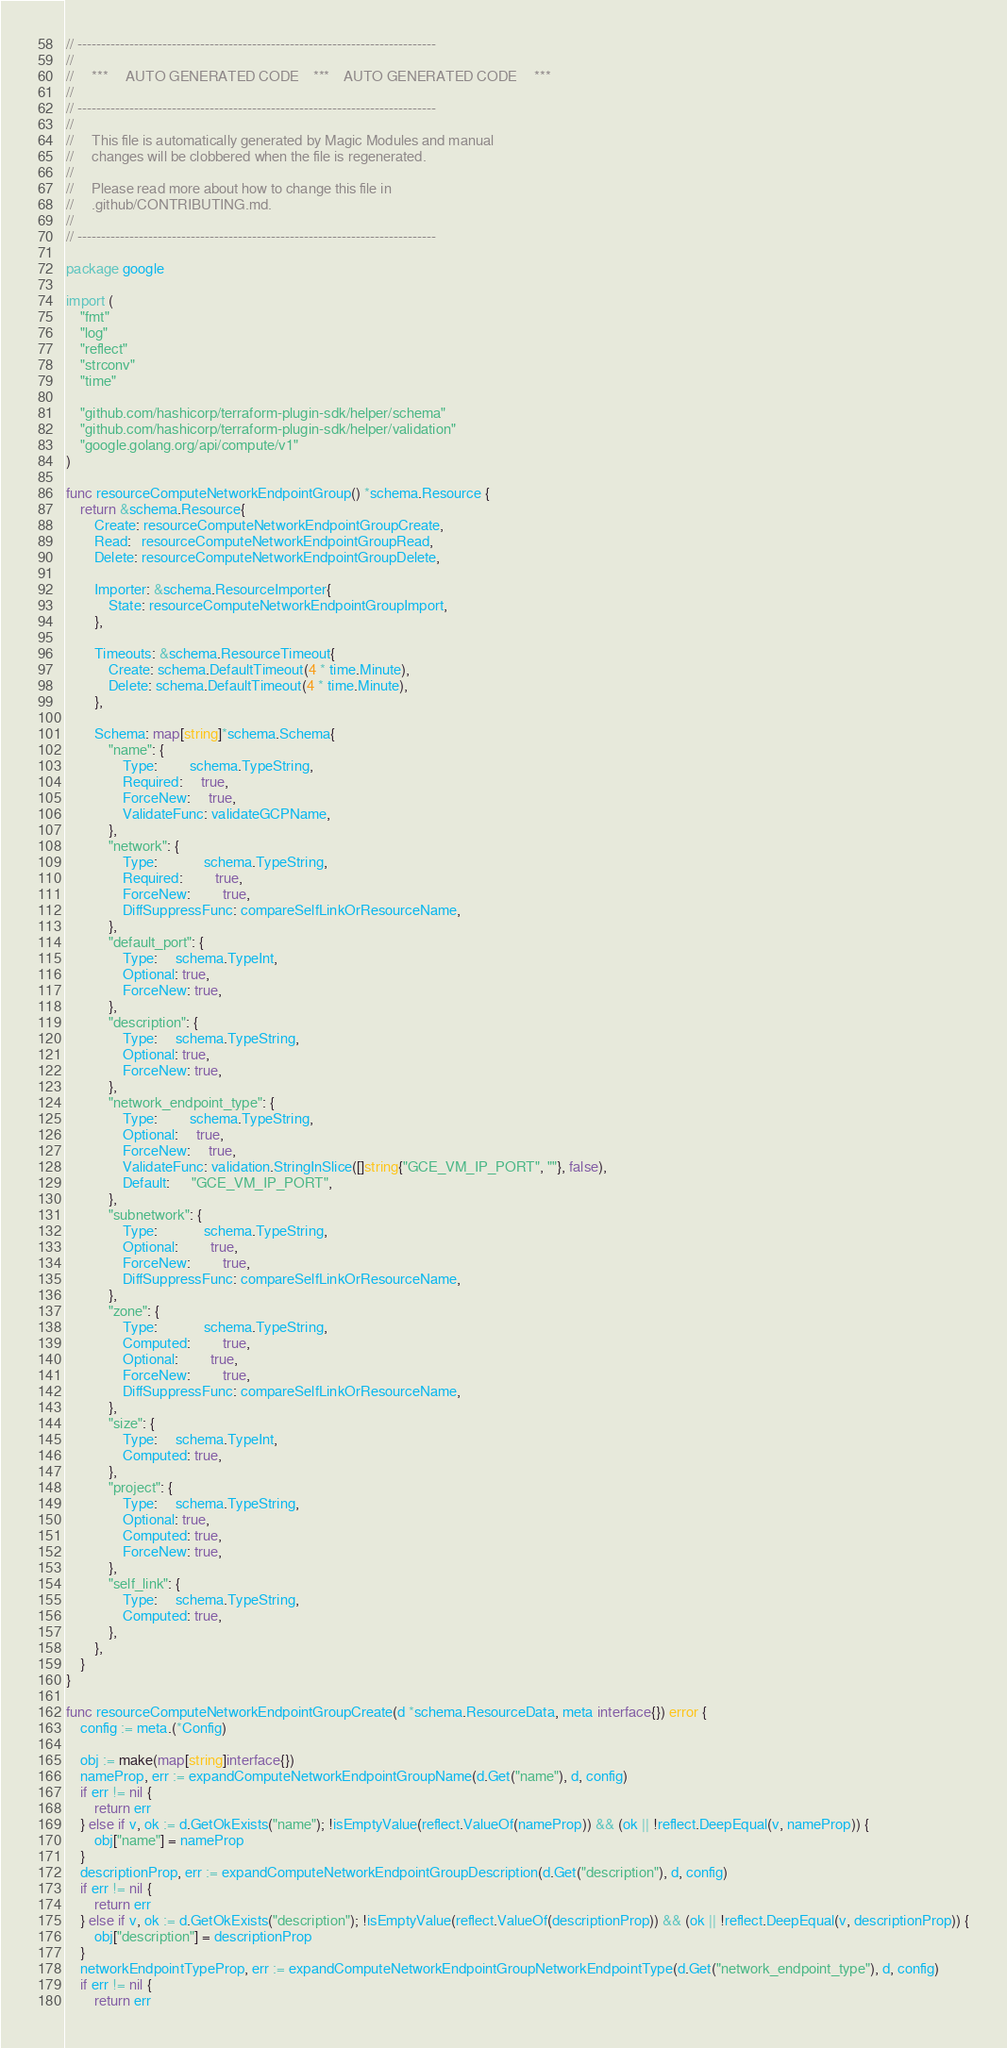<code> <loc_0><loc_0><loc_500><loc_500><_Go_>// ----------------------------------------------------------------------------
//
//     ***     AUTO GENERATED CODE    ***    AUTO GENERATED CODE     ***
//
// ----------------------------------------------------------------------------
//
//     This file is automatically generated by Magic Modules and manual
//     changes will be clobbered when the file is regenerated.
//
//     Please read more about how to change this file in
//     .github/CONTRIBUTING.md.
//
// ----------------------------------------------------------------------------

package google

import (
	"fmt"
	"log"
	"reflect"
	"strconv"
	"time"

	"github.com/hashicorp/terraform-plugin-sdk/helper/schema"
	"github.com/hashicorp/terraform-plugin-sdk/helper/validation"
	"google.golang.org/api/compute/v1"
)

func resourceComputeNetworkEndpointGroup() *schema.Resource {
	return &schema.Resource{
		Create: resourceComputeNetworkEndpointGroupCreate,
		Read:   resourceComputeNetworkEndpointGroupRead,
		Delete: resourceComputeNetworkEndpointGroupDelete,

		Importer: &schema.ResourceImporter{
			State: resourceComputeNetworkEndpointGroupImport,
		},

		Timeouts: &schema.ResourceTimeout{
			Create: schema.DefaultTimeout(4 * time.Minute),
			Delete: schema.DefaultTimeout(4 * time.Minute),
		},

		Schema: map[string]*schema.Schema{
			"name": {
				Type:         schema.TypeString,
				Required:     true,
				ForceNew:     true,
				ValidateFunc: validateGCPName,
			},
			"network": {
				Type:             schema.TypeString,
				Required:         true,
				ForceNew:         true,
				DiffSuppressFunc: compareSelfLinkOrResourceName,
			},
			"default_port": {
				Type:     schema.TypeInt,
				Optional: true,
				ForceNew: true,
			},
			"description": {
				Type:     schema.TypeString,
				Optional: true,
				ForceNew: true,
			},
			"network_endpoint_type": {
				Type:         schema.TypeString,
				Optional:     true,
				ForceNew:     true,
				ValidateFunc: validation.StringInSlice([]string{"GCE_VM_IP_PORT", ""}, false),
				Default:      "GCE_VM_IP_PORT",
			},
			"subnetwork": {
				Type:             schema.TypeString,
				Optional:         true,
				ForceNew:         true,
				DiffSuppressFunc: compareSelfLinkOrResourceName,
			},
			"zone": {
				Type:             schema.TypeString,
				Computed:         true,
				Optional:         true,
				ForceNew:         true,
				DiffSuppressFunc: compareSelfLinkOrResourceName,
			},
			"size": {
				Type:     schema.TypeInt,
				Computed: true,
			},
			"project": {
				Type:     schema.TypeString,
				Optional: true,
				Computed: true,
				ForceNew: true,
			},
			"self_link": {
				Type:     schema.TypeString,
				Computed: true,
			},
		},
	}
}

func resourceComputeNetworkEndpointGroupCreate(d *schema.ResourceData, meta interface{}) error {
	config := meta.(*Config)

	obj := make(map[string]interface{})
	nameProp, err := expandComputeNetworkEndpointGroupName(d.Get("name"), d, config)
	if err != nil {
		return err
	} else if v, ok := d.GetOkExists("name"); !isEmptyValue(reflect.ValueOf(nameProp)) && (ok || !reflect.DeepEqual(v, nameProp)) {
		obj["name"] = nameProp
	}
	descriptionProp, err := expandComputeNetworkEndpointGroupDescription(d.Get("description"), d, config)
	if err != nil {
		return err
	} else if v, ok := d.GetOkExists("description"); !isEmptyValue(reflect.ValueOf(descriptionProp)) && (ok || !reflect.DeepEqual(v, descriptionProp)) {
		obj["description"] = descriptionProp
	}
	networkEndpointTypeProp, err := expandComputeNetworkEndpointGroupNetworkEndpointType(d.Get("network_endpoint_type"), d, config)
	if err != nil {
		return err</code> 